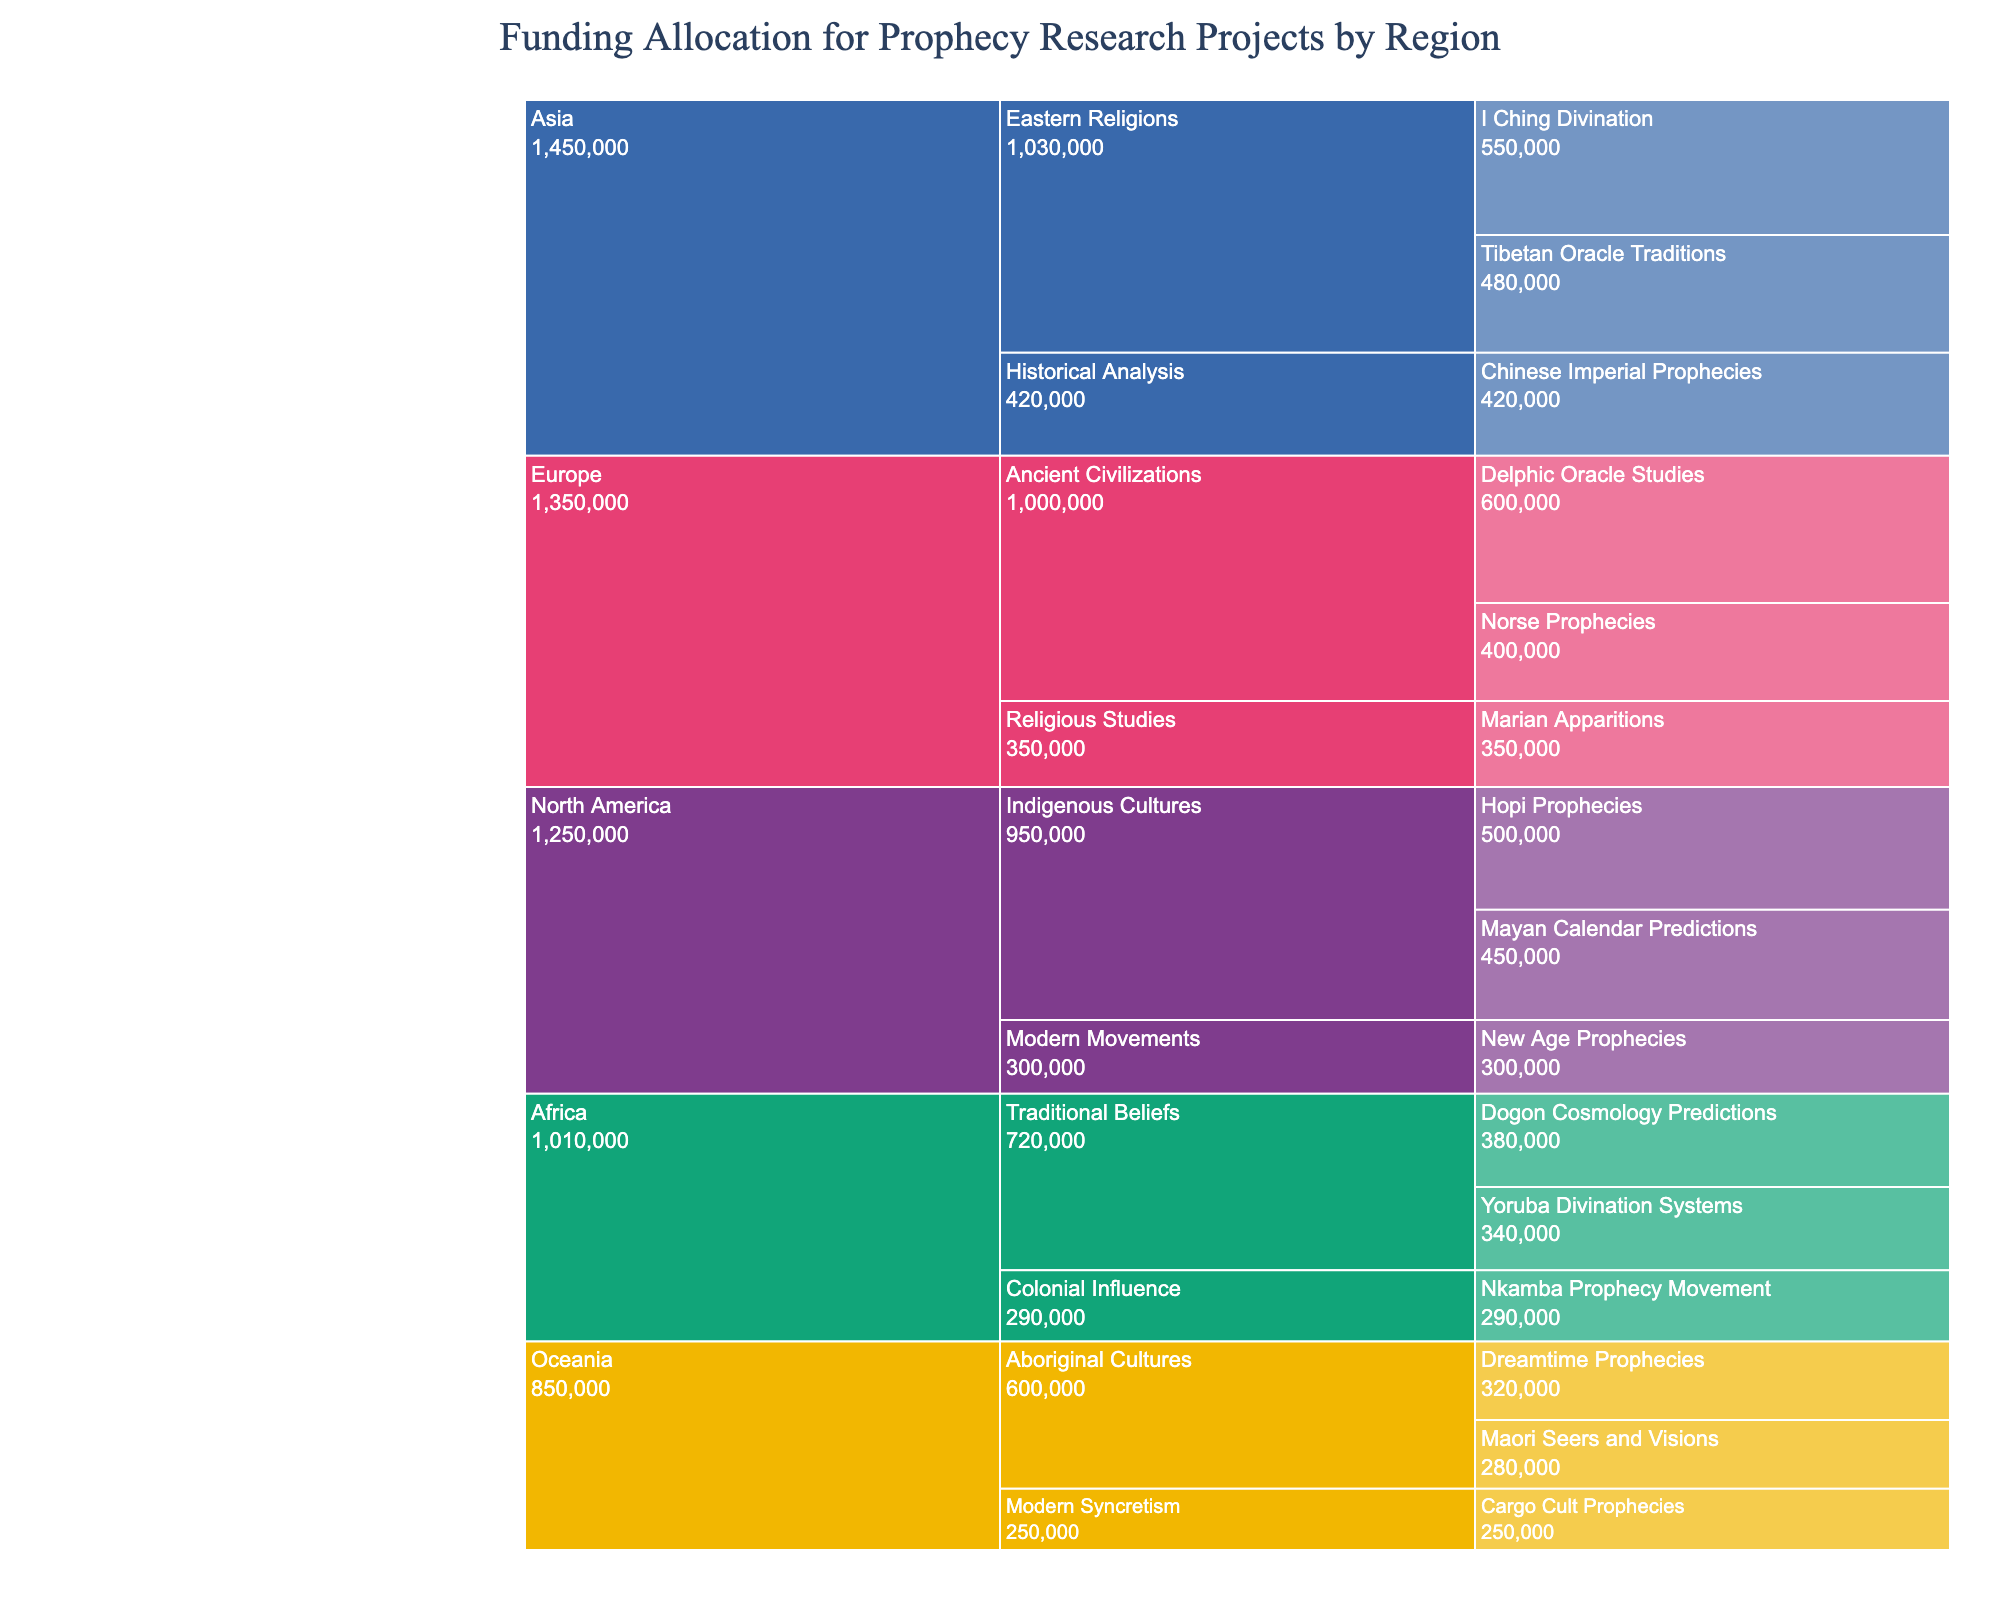what is the title of the figure? The title of the figure is clearly displayed at the top of the chart.
Answer: Funding Allocation for Prophecy Research Projects by Region Which research project received the highest funding? By examining the allocations within each segment, Delphic Oracle Studies has the highest allocation.
Answer: Delphic Oracle Studies How much total funding was allocated to research projects in North America? Sum the individual allocations for North American projects: Hopi Prophecies ($500,000) + Mayan Calendar Predictions ($450,000) + New Age Prophecies ($300,000).
Answer: $1,250,000 Which region has the most diverse range of funding areas? Count the distinct funding areas under each region. Europe and Asia have three distinct funding areas each.
Answer: Europe and Asia Compare the funding between Ancient Civilizations in Europe and Indigenous Cultures in North America. Which one received more funding and by how much? Sum the allocations for Ancient Civilizations (Delphic Oracle Studies $600,000 + Norse Prophecies $400,000 = $1,000,000) and Indigenous Cultures (Hopi Prophecies $500,000 + Mayan Calendar Predictions $450,000 = $950,000). Compare the totals.
Answer: Ancient Civilizations by $50,000 What is the average funding allocation for projects in Oceania? Sum the allocations for all projects in Oceania and divide by the number of projects: (Dreamtime Prophecies $320,000 + Maori Seers and Visions $280,000 + Cargo Cult Prophecies $250,000) / 3.
Answer: $283,333.33 Is the funding for Chinese Imperial Prophecies higher than that for Marian Apparitions? Compare the individual allocations: Chinese Imperial Prophecies $420,000, Marian Apparitions $350,000.
Answer: Yes How much more funding did Eastern Religions in Asia receive compared to Traditional Beliefs in Africa? Sum the allocations for Eastern Religions (I Ching Divination $550,000 + Tibetan Oracle Traditions $480,000) and Traditional Beliefs (Dogon Cosmology Predictions $380,000 + Yoruba Divination Systems $340,000). Subtract the totals.
Answer: $310,000 Identify the funding allocation difference between the highest and lowest funded research projects in Australia? The highest funded project is Dreamtime Prophecies ($320,000) and the lowest is Cargo Cult Prophecies ($250,000). Subtract the lowest from the highest.
Answer: $70,000 Which funding area received the least amount of funding and what was the allocation? The Cargo Cult Prophecies received the least amount of funding at $250,000.
Answer: Cargo Cult Prophecies, $250,000 